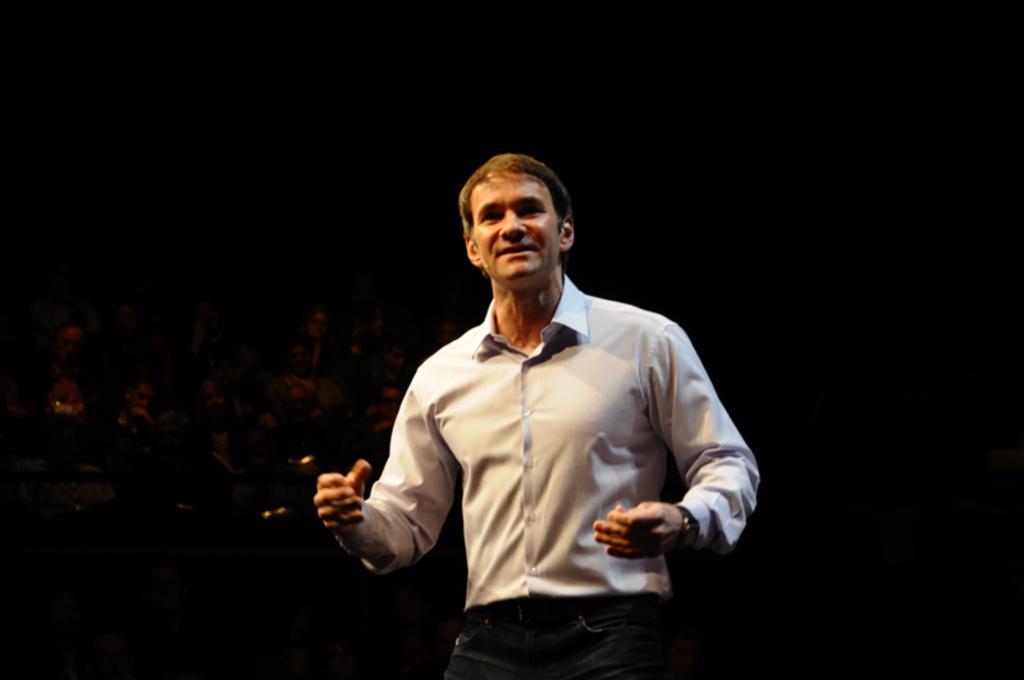How would you summarize this image in a sentence or two? This image consists of a man wearing white shirt and black pant. In the background, there are many people sitting. And the background is dark. 